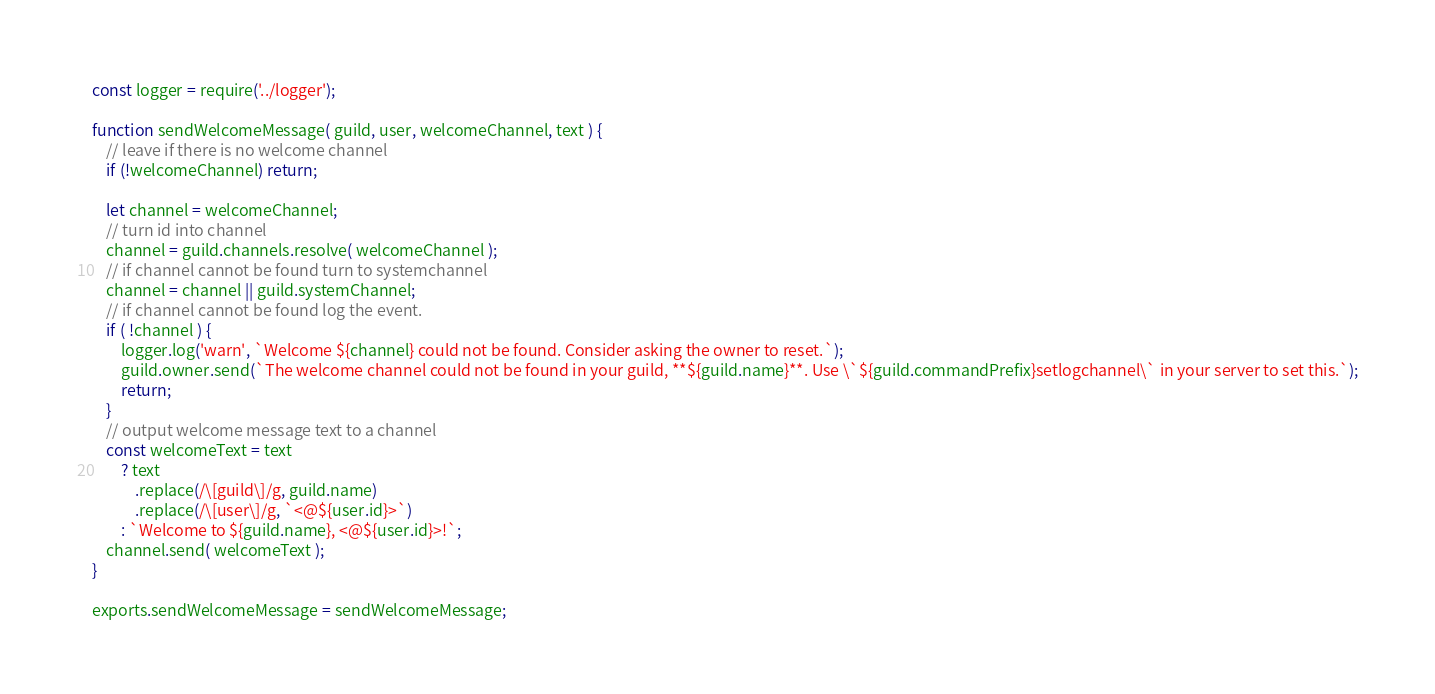<code> <loc_0><loc_0><loc_500><loc_500><_JavaScript_>const logger = require('../logger');

function sendWelcomeMessage( guild, user, welcomeChannel, text ) {
    // leave if there is no welcome channel
    if (!welcomeChannel) return;

    let channel = welcomeChannel;
    // turn id into channel
    channel = guild.channels.resolve( welcomeChannel );
    // if channel cannot be found turn to systemchannel
    channel = channel || guild.systemChannel;
    // if channel cannot be found log the event.
    if ( !channel ) {
        logger.log('warn', `Welcome ${channel} could not be found. Consider asking the owner to reset.`);
        guild.owner.send(`The welcome channel could not be found in your guild, **${guild.name}**. Use \`${guild.commandPrefix}setlogchannel\` in your server to set this.`);
        return;
    }
    // output welcome message text to a channel
    const welcomeText = text
        ? text
            .replace(/\[guild\]/g, guild.name)
            .replace(/\[user\]/g, `<@${user.id}>`)
        : `Welcome to ${guild.name}, <@${user.id}>!`;
    channel.send( welcomeText );
}

exports.sendWelcomeMessage = sendWelcomeMessage;
</code> 